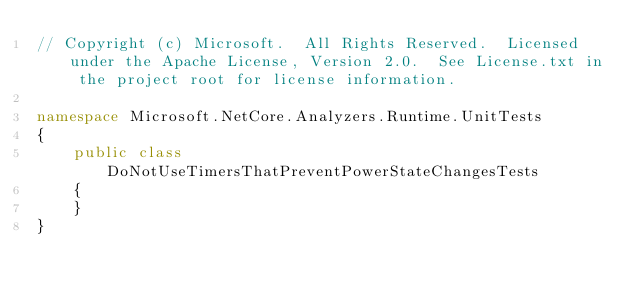Convert code to text. <code><loc_0><loc_0><loc_500><loc_500><_C#_>// Copyright (c) Microsoft.  All Rights Reserved.  Licensed under the Apache License, Version 2.0.  See License.txt in the project root for license information.

namespace Microsoft.NetCore.Analyzers.Runtime.UnitTests
{
    public class DoNotUseTimersThatPreventPowerStateChangesTests
    {
    }
}</code> 